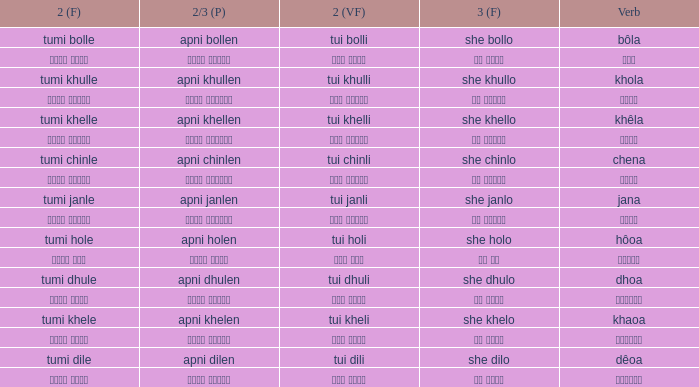What is the 2nd verb for Khola? Tumi khulle. 